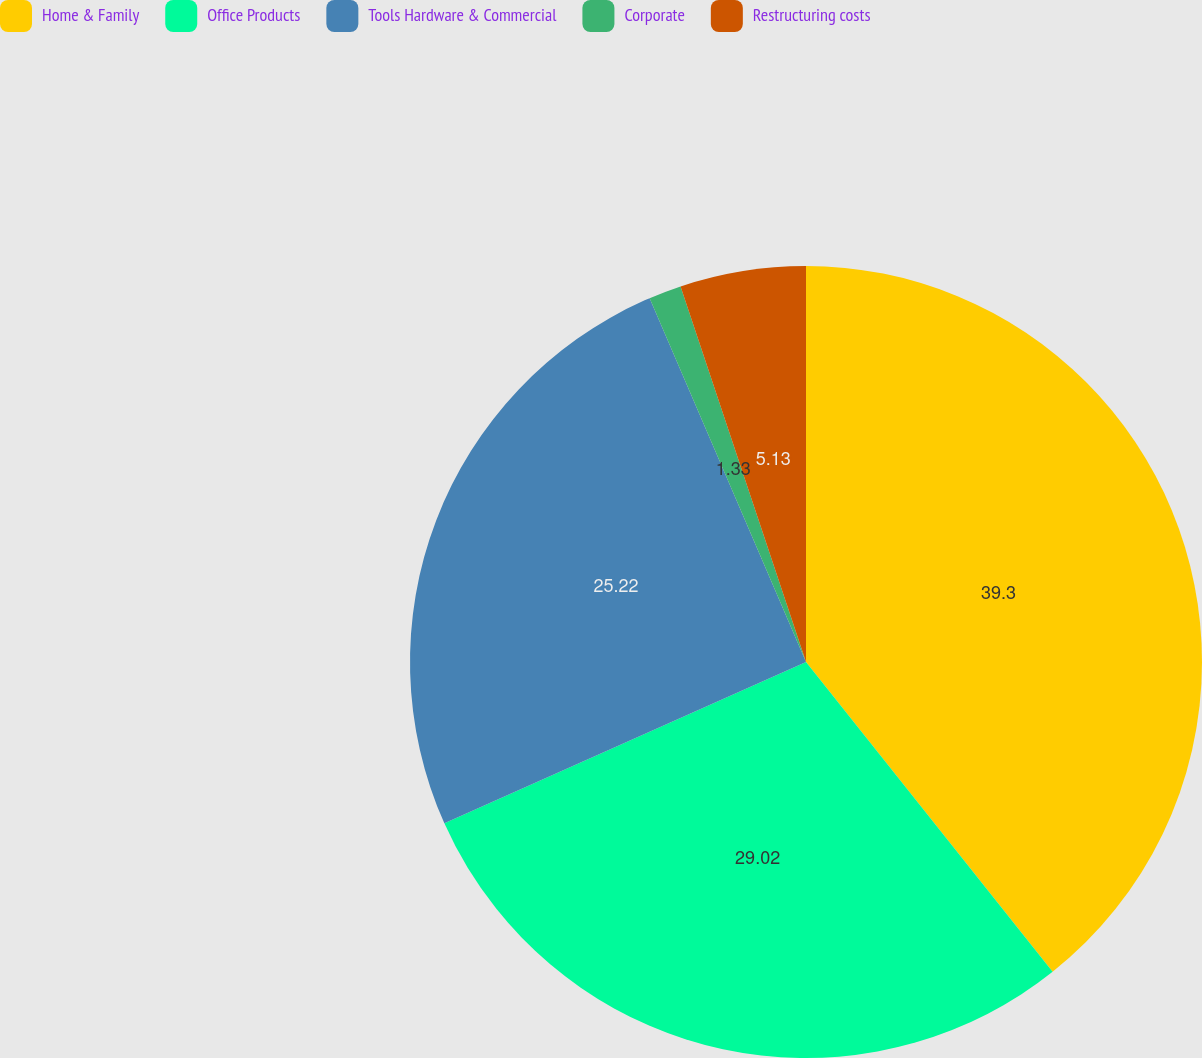Convert chart to OTSL. <chart><loc_0><loc_0><loc_500><loc_500><pie_chart><fcel>Home & Family<fcel>Office Products<fcel>Tools Hardware & Commercial<fcel>Corporate<fcel>Restructuring costs<nl><fcel>39.3%<fcel>29.02%<fcel>25.22%<fcel>1.33%<fcel>5.13%<nl></chart> 